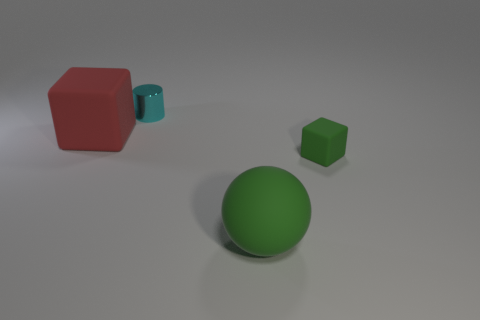Add 2 green matte cylinders. How many objects exist? 6 Subtract all green cubes. How many cubes are left? 1 Subtract all balls. How many objects are left? 3 Subtract all cyan objects. Subtract all small cubes. How many objects are left? 2 Add 4 small cyan metal cylinders. How many small cyan metal cylinders are left? 5 Add 1 gray rubber cylinders. How many gray rubber cylinders exist? 1 Subtract 0 yellow cubes. How many objects are left? 4 Subtract all green cylinders. Subtract all yellow balls. How many cylinders are left? 1 Subtract all gray balls. How many red blocks are left? 1 